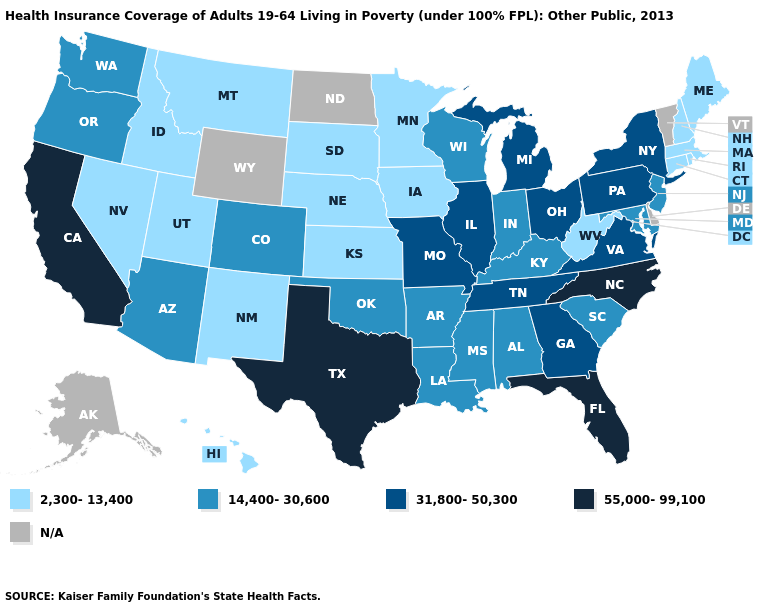What is the value of Indiana?
Quick response, please. 14,400-30,600. Name the states that have a value in the range 2,300-13,400?
Answer briefly. Connecticut, Hawaii, Idaho, Iowa, Kansas, Maine, Massachusetts, Minnesota, Montana, Nebraska, Nevada, New Hampshire, New Mexico, Rhode Island, South Dakota, Utah, West Virginia. What is the highest value in the South ?
Write a very short answer. 55,000-99,100. What is the lowest value in the USA?
Quick response, please. 2,300-13,400. What is the value of Rhode Island?
Quick response, please. 2,300-13,400. Name the states that have a value in the range N/A?
Give a very brief answer. Alaska, Delaware, North Dakota, Vermont, Wyoming. Is the legend a continuous bar?
Concise answer only. No. Does Wisconsin have the lowest value in the MidWest?
Concise answer only. No. Name the states that have a value in the range 14,400-30,600?
Be succinct. Alabama, Arizona, Arkansas, Colorado, Indiana, Kentucky, Louisiana, Maryland, Mississippi, New Jersey, Oklahoma, Oregon, South Carolina, Washington, Wisconsin. Among the states that border Iowa , which have the highest value?
Answer briefly. Illinois, Missouri. What is the value of Arkansas?
Be succinct. 14,400-30,600. How many symbols are there in the legend?
Concise answer only. 5. Does Indiana have the lowest value in the USA?
Give a very brief answer. No. What is the lowest value in the South?
Be succinct. 2,300-13,400. 